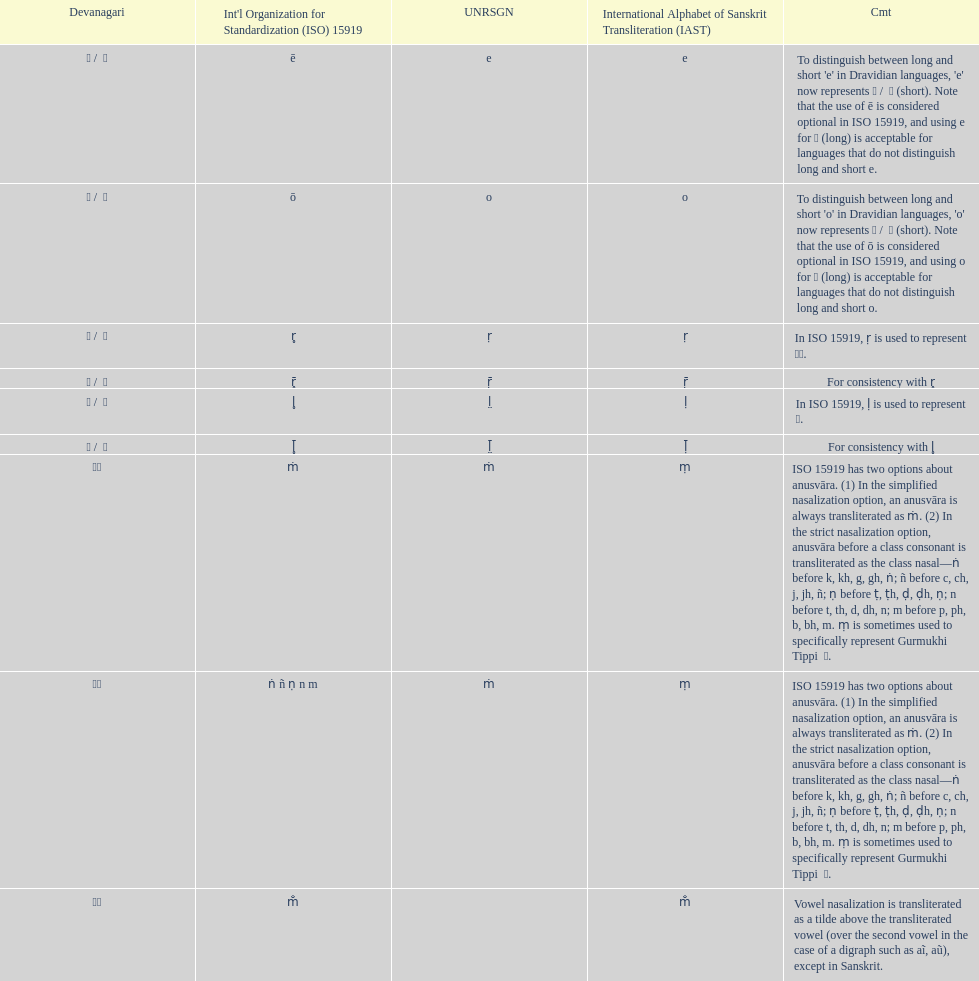What is listed previous to in iso 15919, &#7735; is used to represent &#2355;. under comments? For consistency with r̥. 